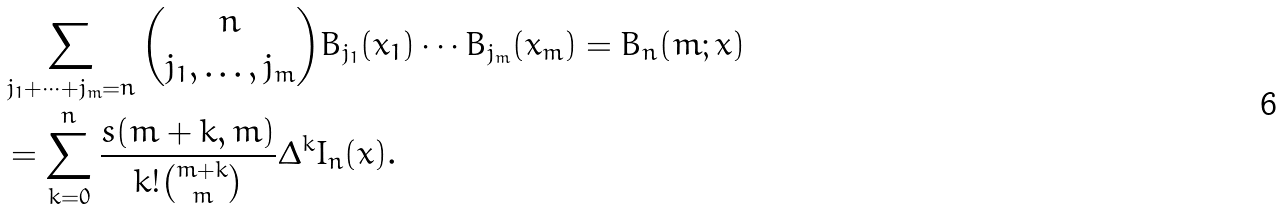<formula> <loc_0><loc_0><loc_500><loc_500>& \sum _ { j _ { 1 } + \cdots + j _ { m } = n } \binom { n } { j _ { 1 } , \dots , j _ { m } } B _ { j _ { 1 } } ( x _ { 1 } ) \cdots B _ { j _ { m } } ( x _ { m } ) = B _ { n } ( m ; x ) \\ & = \sum _ { k = 0 } ^ { n } \frac { s ( m + k , m ) } { k ! \binom { m + k } { m } } \Delta ^ { k } I _ { n } ( x ) .</formula> 